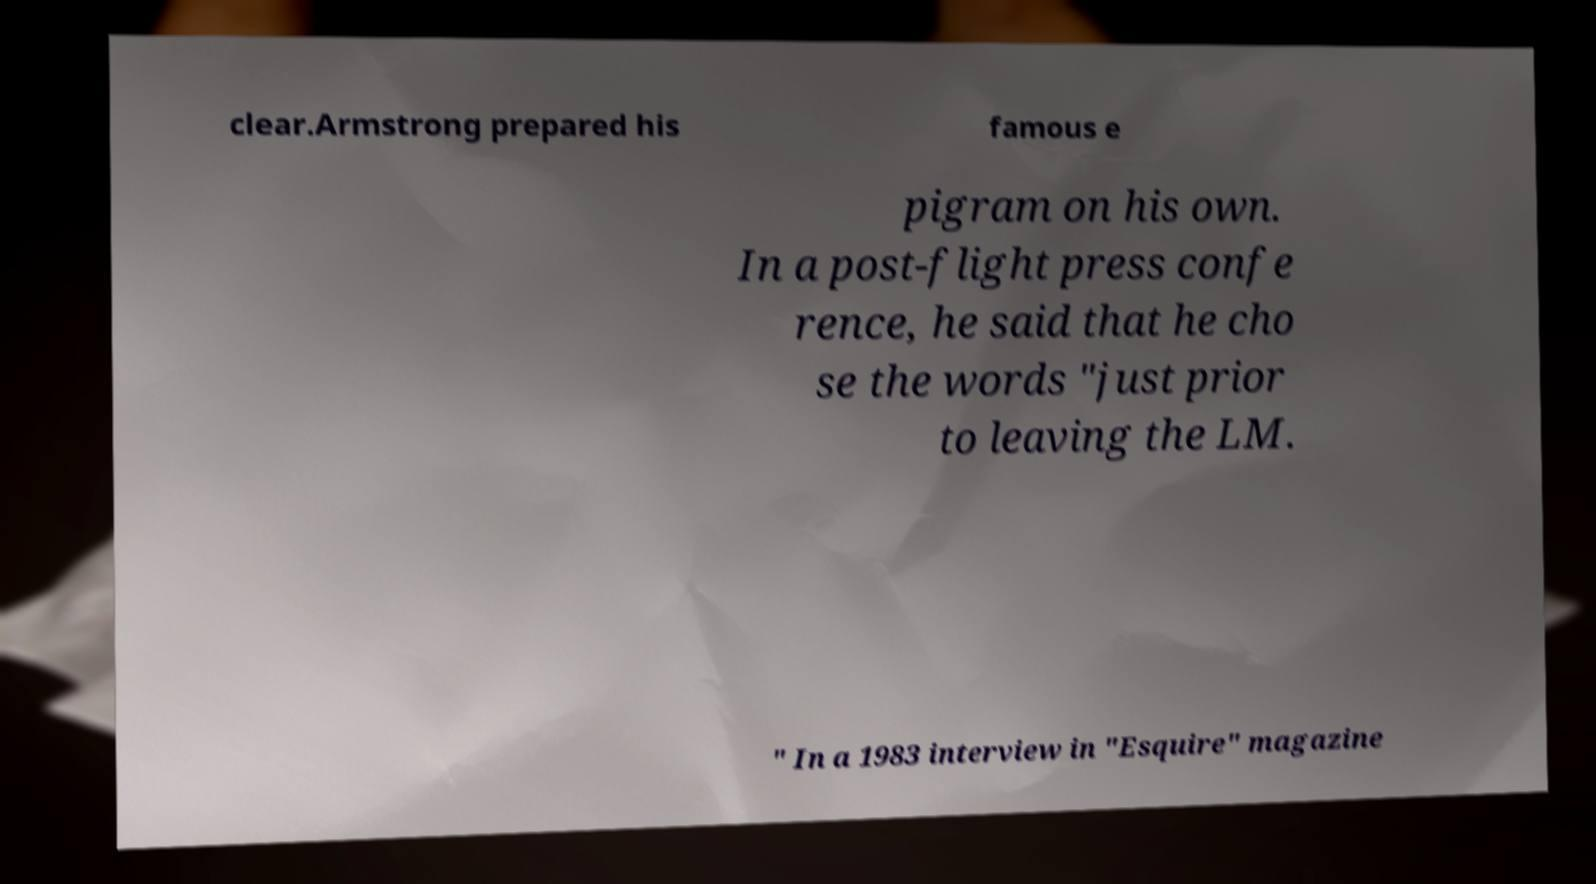For documentation purposes, I need the text within this image transcribed. Could you provide that? clear.Armstrong prepared his famous e pigram on his own. In a post-flight press confe rence, he said that he cho se the words "just prior to leaving the LM. " In a 1983 interview in "Esquire" magazine 